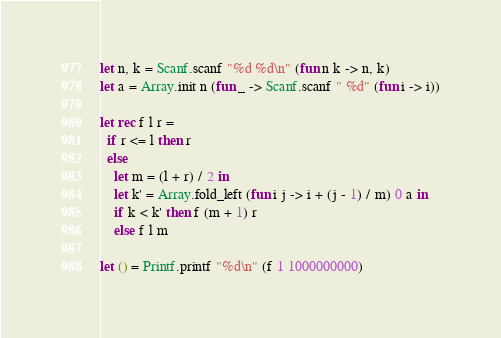Convert code to text. <code><loc_0><loc_0><loc_500><loc_500><_OCaml_>let n, k = Scanf.scanf "%d %d\n" (fun n k -> n, k)
let a = Array.init n (fun _ -> Scanf.scanf " %d" (fun i -> i))

let rec f l r =
  if r <= l then r
  else
    let m = (l + r) / 2 in
    let k' = Array.fold_left (fun i j -> i + (j - 1) / m) 0 a in
    if k < k' then f (m + 1) r
    else f l m

let () = Printf.printf "%d\n" (f 1 1000000000)
</code> 